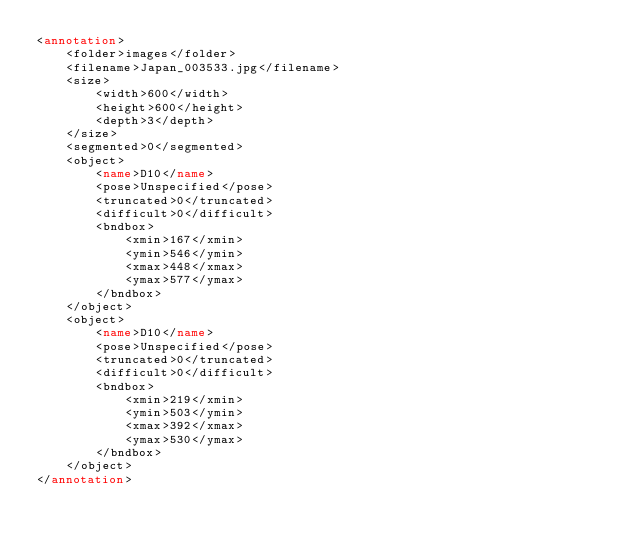<code> <loc_0><loc_0><loc_500><loc_500><_XML_><annotation>
	<folder>images</folder>
	<filename>Japan_003533.jpg</filename>
	<size>
		<width>600</width>
		<height>600</height>
		<depth>3</depth>
	</size>
	<segmented>0</segmented>
	<object>
		<name>D10</name>
		<pose>Unspecified</pose>
		<truncated>0</truncated>
		<difficult>0</difficult>
		<bndbox>
			<xmin>167</xmin>
			<ymin>546</ymin>
			<xmax>448</xmax>
			<ymax>577</ymax>
		</bndbox>
	</object>
	<object>
		<name>D10</name>
		<pose>Unspecified</pose>
		<truncated>0</truncated>
		<difficult>0</difficult>
		<bndbox>
			<xmin>219</xmin>
			<ymin>503</ymin>
			<xmax>392</xmax>
			<ymax>530</ymax>
		</bndbox>
	</object>
</annotation></code> 